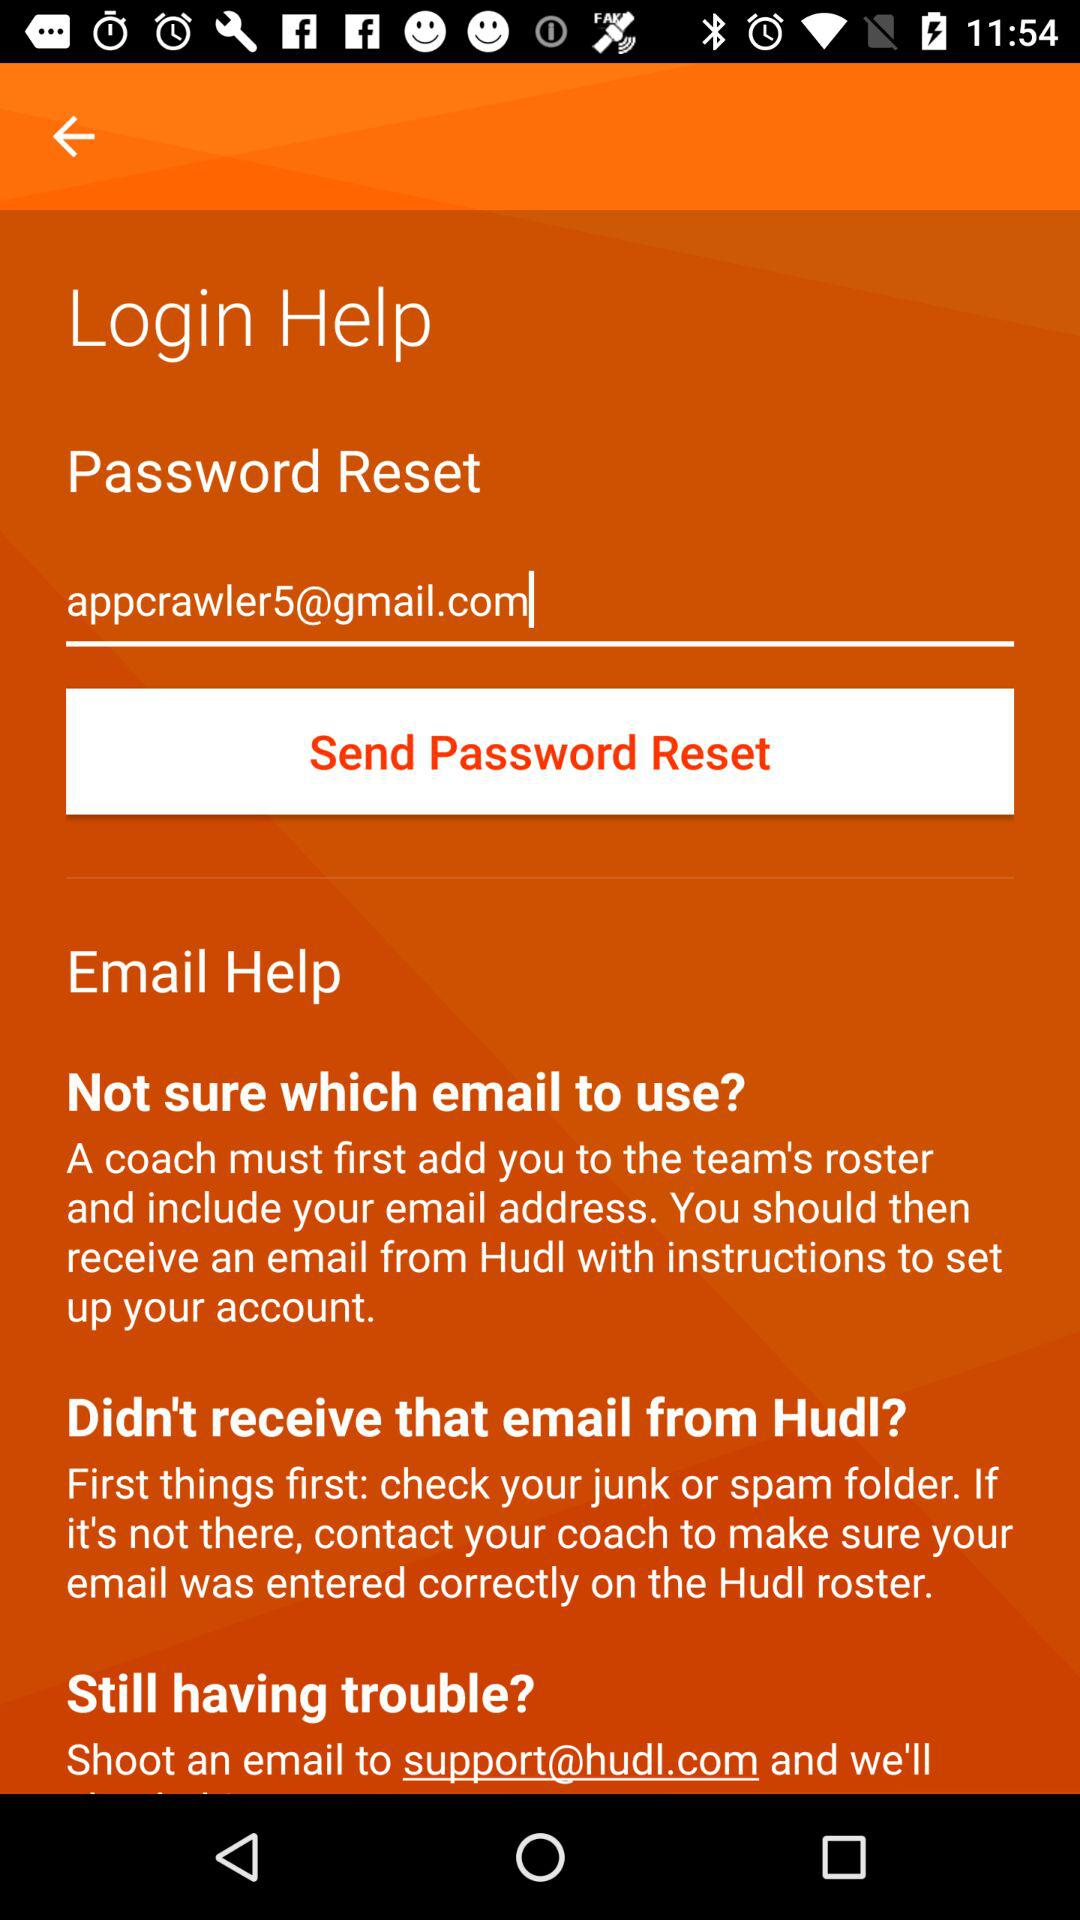Has the password reset been sent?
When the provided information is insufficient, respond with <no answer>. <no answer> 